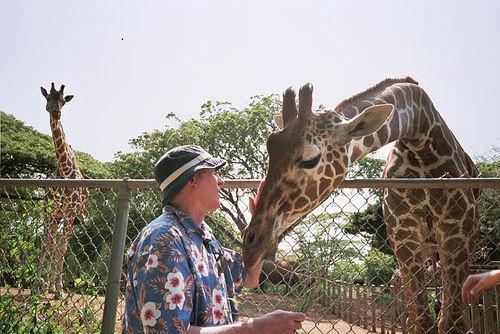How many giraffes are interacting with the man?

Choices:
A) two
B) three
C) four
D) one one 